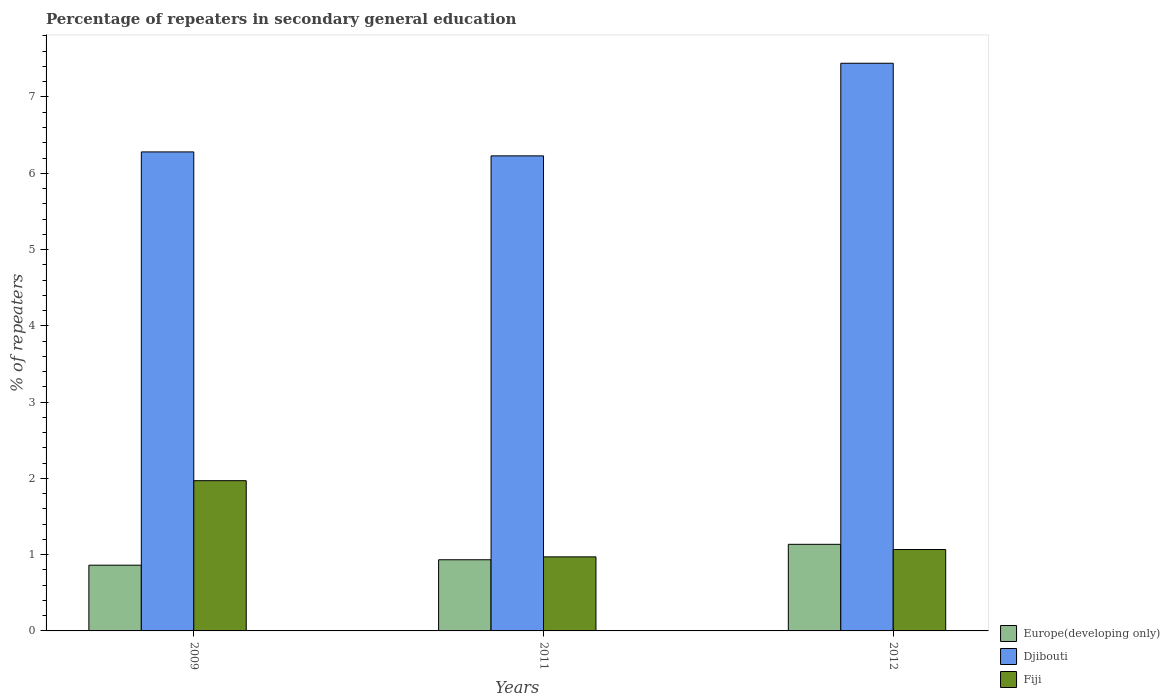How many groups of bars are there?
Make the answer very short. 3. Are the number of bars per tick equal to the number of legend labels?
Your response must be concise. Yes. Are the number of bars on each tick of the X-axis equal?
Your response must be concise. Yes. How many bars are there on the 2nd tick from the right?
Provide a succinct answer. 3. In how many cases, is the number of bars for a given year not equal to the number of legend labels?
Offer a very short reply. 0. What is the percentage of repeaters in secondary general education in Fiji in 2011?
Ensure brevity in your answer.  0.97. Across all years, what is the maximum percentage of repeaters in secondary general education in Djibouti?
Make the answer very short. 7.44. Across all years, what is the minimum percentage of repeaters in secondary general education in Djibouti?
Your response must be concise. 6.23. In which year was the percentage of repeaters in secondary general education in Europe(developing only) minimum?
Provide a succinct answer. 2009. What is the total percentage of repeaters in secondary general education in Europe(developing only) in the graph?
Provide a succinct answer. 2.93. What is the difference between the percentage of repeaters in secondary general education in Europe(developing only) in 2009 and that in 2011?
Keep it short and to the point. -0.07. What is the difference between the percentage of repeaters in secondary general education in Europe(developing only) in 2009 and the percentage of repeaters in secondary general education in Fiji in 2012?
Your answer should be very brief. -0.21. What is the average percentage of repeaters in secondary general education in Fiji per year?
Make the answer very short. 1.34. In the year 2012, what is the difference between the percentage of repeaters in secondary general education in Europe(developing only) and percentage of repeaters in secondary general education in Djibouti?
Your response must be concise. -6.31. In how many years, is the percentage of repeaters in secondary general education in Europe(developing only) greater than 6.8 %?
Make the answer very short. 0. What is the ratio of the percentage of repeaters in secondary general education in Europe(developing only) in 2011 to that in 2012?
Offer a very short reply. 0.82. Is the difference between the percentage of repeaters in secondary general education in Europe(developing only) in 2011 and 2012 greater than the difference between the percentage of repeaters in secondary general education in Djibouti in 2011 and 2012?
Provide a short and direct response. Yes. What is the difference between the highest and the second highest percentage of repeaters in secondary general education in Djibouti?
Your answer should be very brief. 1.16. What is the difference between the highest and the lowest percentage of repeaters in secondary general education in Djibouti?
Your answer should be very brief. 1.21. In how many years, is the percentage of repeaters in secondary general education in Fiji greater than the average percentage of repeaters in secondary general education in Fiji taken over all years?
Offer a very short reply. 1. Is the sum of the percentage of repeaters in secondary general education in Europe(developing only) in 2009 and 2012 greater than the maximum percentage of repeaters in secondary general education in Fiji across all years?
Provide a short and direct response. Yes. What does the 3rd bar from the left in 2012 represents?
Keep it short and to the point. Fiji. What does the 2nd bar from the right in 2009 represents?
Provide a short and direct response. Djibouti. Is it the case that in every year, the sum of the percentage of repeaters in secondary general education in Djibouti and percentage of repeaters in secondary general education in Europe(developing only) is greater than the percentage of repeaters in secondary general education in Fiji?
Give a very brief answer. Yes. How many bars are there?
Your answer should be compact. 9. Are the values on the major ticks of Y-axis written in scientific E-notation?
Provide a short and direct response. No. Does the graph contain any zero values?
Your answer should be very brief. No. Does the graph contain grids?
Ensure brevity in your answer.  No. How many legend labels are there?
Your response must be concise. 3. What is the title of the graph?
Make the answer very short. Percentage of repeaters in secondary general education. What is the label or title of the Y-axis?
Provide a succinct answer. % of repeaters. What is the % of repeaters in Europe(developing only) in 2009?
Give a very brief answer. 0.86. What is the % of repeaters in Djibouti in 2009?
Your answer should be compact. 6.28. What is the % of repeaters of Fiji in 2009?
Provide a short and direct response. 1.97. What is the % of repeaters of Europe(developing only) in 2011?
Provide a succinct answer. 0.93. What is the % of repeaters of Djibouti in 2011?
Ensure brevity in your answer.  6.23. What is the % of repeaters of Fiji in 2011?
Provide a short and direct response. 0.97. What is the % of repeaters in Europe(developing only) in 2012?
Offer a terse response. 1.14. What is the % of repeaters of Djibouti in 2012?
Offer a very short reply. 7.44. What is the % of repeaters in Fiji in 2012?
Give a very brief answer. 1.07. Across all years, what is the maximum % of repeaters in Europe(developing only)?
Offer a terse response. 1.14. Across all years, what is the maximum % of repeaters in Djibouti?
Keep it short and to the point. 7.44. Across all years, what is the maximum % of repeaters in Fiji?
Your answer should be very brief. 1.97. Across all years, what is the minimum % of repeaters of Europe(developing only)?
Offer a terse response. 0.86. Across all years, what is the minimum % of repeaters of Djibouti?
Keep it short and to the point. 6.23. Across all years, what is the minimum % of repeaters of Fiji?
Keep it short and to the point. 0.97. What is the total % of repeaters in Europe(developing only) in the graph?
Offer a terse response. 2.93. What is the total % of repeaters of Djibouti in the graph?
Your answer should be very brief. 19.95. What is the total % of repeaters of Fiji in the graph?
Offer a very short reply. 4.01. What is the difference between the % of repeaters of Europe(developing only) in 2009 and that in 2011?
Your answer should be compact. -0.07. What is the difference between the % of repeaters in Djibouti in 2009 and that in 2011?
Your answer should be compact. 0.05. What is the difference between the % of repeaters of Europe(developing only) in 2009 and that in 2012?
Make the answer very short. -0.27. What is the difference between the % of repeaters of Djibouti in 2009 and that in 2012?
Your answer should be compact. -1.16. What is the difference between the % of repeaters in Fiji in 2009 and that in 2012?
Make the answer very short. 0.9. What is the difference between the % of repeaters of Europe(developing only) in 2011 and that in 2012?
Your answer should be compact. -0.2. What is the difference between the % of repeaters in Djibouti in 2011 and that in 2012?
Provide a succinct answer. -1.21. What is the difference between the % of repeaters in Fiji in 2011 and that in 2012?
Offer a terse response. -0.1. What is the difference between the % of repeaters of Europe(developing only) in 2009 and the % of repeaters of Djibouti in 2011?
Offer a terse response. -5.37. What is the difference between the % of repeaters in Europe(developing only) in 2009 and the % of repeaters in Fiji in 2011?
Your response must be concise. -0.11. What is the difference between the % of repeaters of Djibouti in 2009 and the % of repeaters of Fiji in 2011?
Provide a succinct answer. 5.31. What is the difference between the % of repeaters in Europe(developing only) in 2009 and the % of repeaters in Djibouti in 2012?
Keep it short and to the point. -6.58. What is the difference between the % of repeaters in Europe(developing only) in 2009 and the % of repeaters in Fiji in 2012?
Keep it short and to the point. -0.21. What is the difference between the % of repeaters of Djibouti in 2009 and the % of repeaters of Fiji in 2012?
Keep it short and to the point. 5.21. What is the difference between the % of repeaters of Europe(developing only) in 2011 and the % of repeaters of Djibouti in 2012?
Give a very brief answer. -6.51. What is the difference between the % of repeaters of Europe(developing only) in 2011 and the % of repeaters of Fiji in 2012?
Your answer should be very brief. -0.13. What is the difference between the % of repeaters of Djibouti in 2011 and the % of repeaters of Fiji in 2012?
Offer a very short reply. 5.16. What is the average % of repeaters in Europe(developing only) per year?
Offer a terse response. 0.98. What is the average % of repeaters of Djibouti per year?
Your answer should be compact. 6.65. What is the average % of repeaters in Fiji per year?
Give a very brief answer. 1.34. In the year 2009, what is the difference between the % of repeaters in Europe(developing only) and % of repeaters in Djibouti?
Offer a terse response. -5.42. In the year 2009, what is the difference between the % of repeaters in Europe(developing only) and % of repeaters in Fiji?
Offer a very short reply. -1.11. In the year 2009, what is the difference between the % of repeaters of Djibouti and % of repeaters of Fiji?
Your answer should be very brief. 4.31. In the year 2011, what is the difference between the % of repeaters of Europe(developing only) and % of repeaters of Djibouti?
Offer a very short reply. -5.3. In the year 2011, what is the difference between the % of repeaters of Europe(developing only) and % of repeaters of Fiji?
Ensure brevity in your answer.  -0.04. In the year 2011, what is the difference between the % of repeaters of Djibouti and % of repeaters of Fiji?
Provide a succinct answer. 5.26. In the year 2012, what is the difference between the % of repeaters in Europe(developing only) and % of repeaters in Djibouti?
Ensure brevity in your answer.  -6.31. In the year 2012, what is the difference between the % of repeaters of Europe(developing only) and % of repeaters of Fiji?
Offer a terse response. 0.07. In the year 2012, what is the difference between the % of repeaters in Djibouti and % of repeaters in Fiji?
Provide a succinct answer. 6.38. What is the ratio of the % of repeaters in Europe(developing only) in 2009 to that in 2011?
Make the answer very short. 0.92. What is the ratio of the % of repeaters of Djibouti in 2009 to that in 2011?
Your response must be concise. 1.01. What is the ratio of the % of repeaters in Fiji in 2009 to that in 2011?
Your response must be concise. 2.03. What is the ratio of the % of repeaters in Europe(developing only) in 2009 to that in 2012?
Offer a very short reply. 0.76. What is the ratio of the % of repeaters in Djibouti in 2009 to that in 2012?
Your response must be concise. 0.84. What is the ratio of the % of repeaters in Fiji in 2009 to that in 2012?
Ensure brevity in your answer.  1.85. What is the ratio of the % of repeaters of Europe(developing only) in 2011 to that in 2012?
Offer a very short reply. 0.82. What is the ratio of the % of repeaters of Djibouti in 2011 to that in 2012?
Provide a short and direct response. 0.84. What is the ratio of the % of repeaters in Fiji in 2011 to that in 2012?
Your response must be concise. 0.91. What is the difference between the highest and the second highest % of repeaters of Europe(developing only)?
Your response must be concise. 0.2. What is the difference between the highest and the second highest % of repeaters in Djibouti?
Provide a succinct answer. 1.16. What is the difference between the highest and the second highest % of repeaters in Fiji?
Keep it short and to the point. 0.9. What is the difference between the highest and the lowest % of repeaters in Europe(developing only)?
Provide a succinct answer. 0.27. What is the difference between the highest and the lowest % of repeaters of Djibouti?
Provide a short and direct response. 1.21. What is the difference between the highest and the lowest % of repeaters in Fiji?
Your answer should be very brief. 1. 